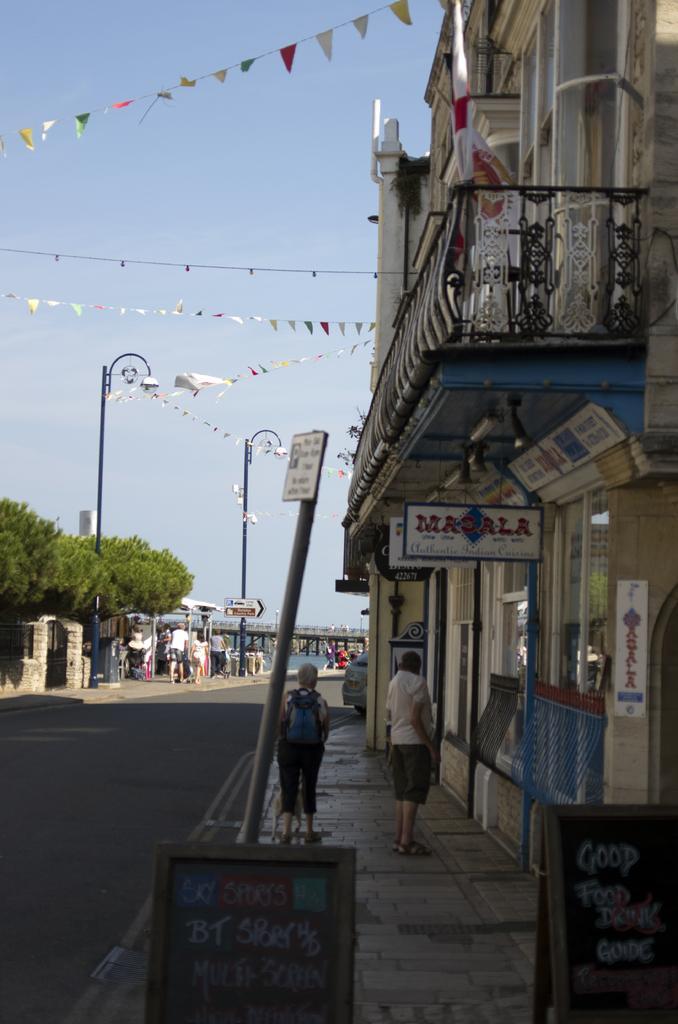Could you give a brief overview of what you see in this image? In this image we can see two persons standing on the path. One person wearing a bag. to the right side, we can see a sign board, a building, metal fence and a flag. In the background, we can see a group of people standing on the road, group of poles, trees, bridge, ribbons and sky. 